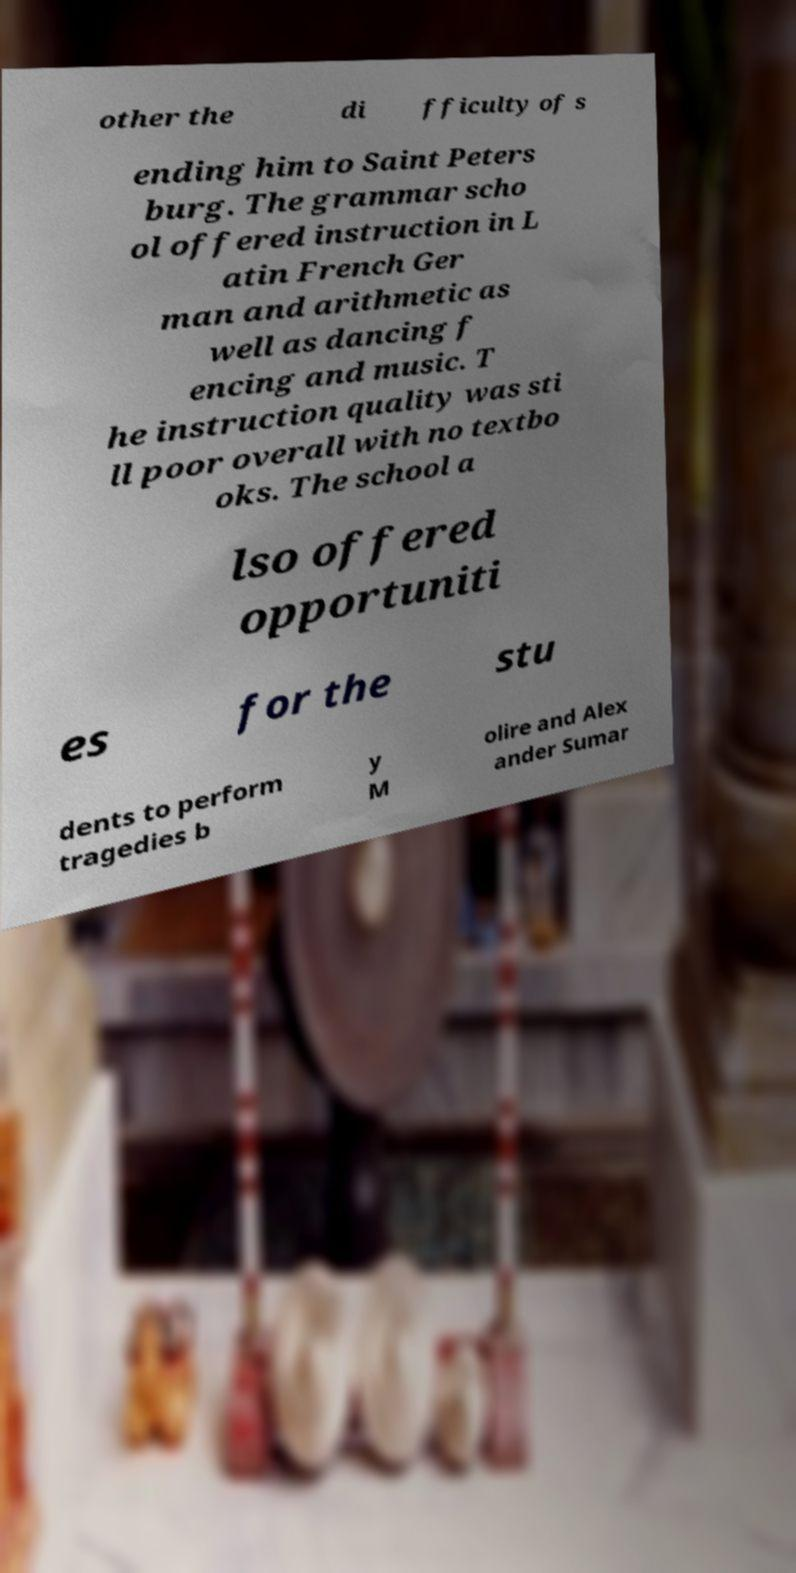For documentation purposes, I need the text within this image transcribed. Could you provide that? other the di fficulty of s ending him to Saint Peters burg. The grammar scho ol offered instruction in L atin French Ger man and arithmetic as well as dancing f encing and music. T he instruction quality was sti ll poor overall with no textbo oks. The school a lso offered opportuniti es for the stu dents to perform tragedies b y M olire and Alex ander Sumar 